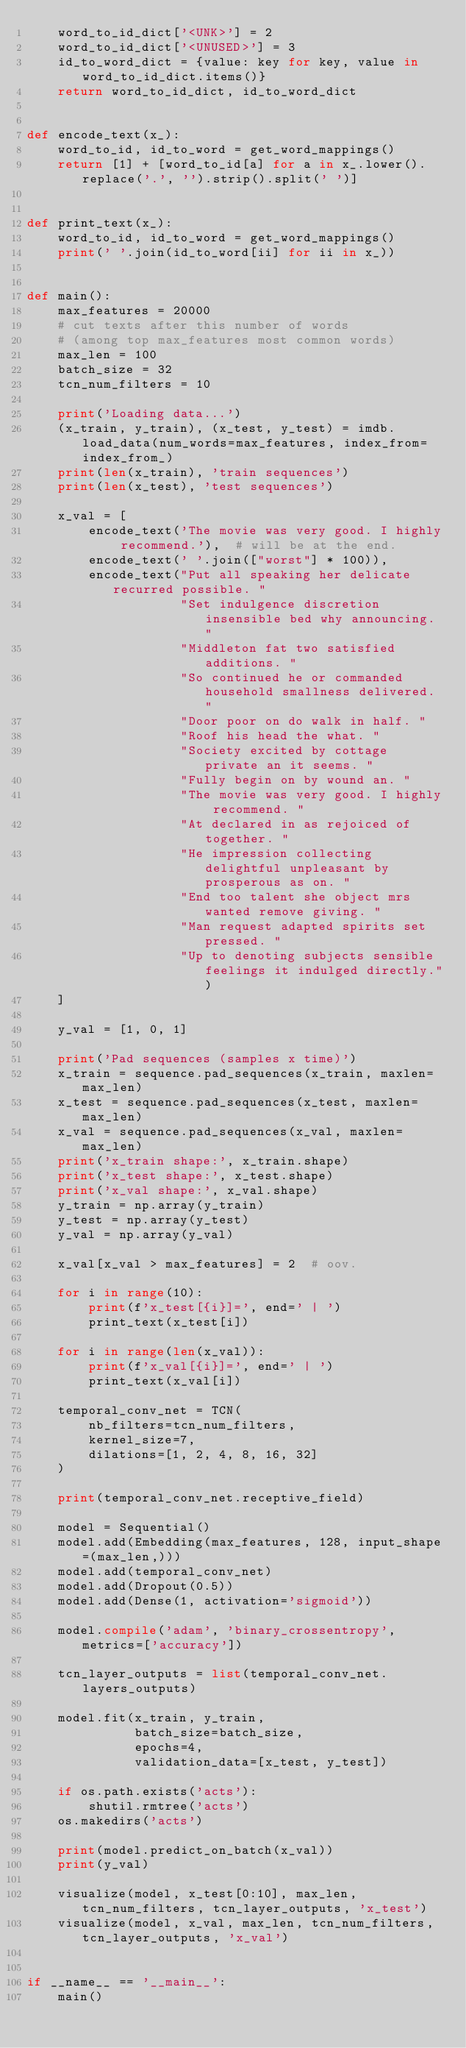Convert code to text. <code><loc_0><loc_0><loc_500><loc_500><_Python_>    word_to_id_dict['<UNK>'] = 2
    word_to_id_dict['<UNUSED>'] = 3
    id_to_word_dict = {value: key for key, value in word_to_id_dict.items()}
    return word_to_id_dict, id_to_word_dict


def encode_text(x_):
    word_to_id, id_to_word = get_word_mappings()
    return [1] + [word_to_id[a] for a in x_.lower().replace('.', '').strip().split(' ')]


def print_text(x_):
    word_to_id, id_to_word = get_word_mappings()
    print(' '.join(id_to_word[ii] for ii in x_))


def main():
    max_features = 20000
    # cut texts after this number of words
    # (among top max_features most common words)
    max_len = 100
    batch_size = 32
    tcn_num_filters = 10

    print('Loading data...')
    (x_train, y_train), (x_test, y_test) = imdb.load_data(num_words=max_features, index_from=index_from_)
    print(len(x_train), 'train sequences')
    print(len(x_test), 'test sequences')

    x_val = [
        encode_text('The movie was very good. I highly recommend.'),  # will be at the end.
        encode_text(' '.join(["worst"] * 100)),
        encode_text("Put all speaking her delicate recurred possible. "
                    "Set indulgence discretion insensible bed why announcing. "
                    "Middleton fat two satisfied additions. "
                    "So continued he or commanded household smallness delivered. "
                    "Door poor on do walk in half. "
                    "Roof his head the what. "
                    "Society excited by cottage private an it seems. "
                    "Fully begin on by wound an. "
                    "The movie was very good. I highly recommend. "
                    "At declared in as rejoiced of together. "
                    "He impression collecting delightful unpleasant by prosperous as on. "
                    "End too talent she object mrs wanted remove giving. "
                    "Man request adapted spirits set pressed. "
                    "Up to denoting subjects sensible feelings it indulged directly.")
    ]

    y_val = [1, 0, 1]

    print('Pad sequences (samples x time)')
    x_train = sequence.pad_sequences(x_train, maxlen=max_len)
    x_test = sequence.pad_sequences(x_test, maxlen=max_len)
    x_val = sequence.pad_sequences(x_val, maxlen=max_len)
    print('x_train shape:', x_train.shape)
    print('x_test shape:', x_test.shape)
    print('x_val shape:', x_val.shape)
    y_train = np.array(y_train)
    y_test = np.array(y_test)
    y_val = np.array(y_val)

    x_val[x_val > max_features] = 2  # oov.

    for i in range(10):
        print(f'x_test[{i}]=', end=' | ')
        print_text(x_test[i])

    for i in range(len(x_val)):
        print(f'x_val[{i}]=', end=' | ')
        print_text(x_val[i])

    temporal_conv_net = TCN(
        nb_filters=tcn_num_filters,
        kernel_size=7,
        dilations=[1, 2, 4, 8, 16, 32]
    )

    print(temporal_conv_net.receptive_field)

    model = Sequential()
    model.add(Embedding(max_features, 128, input_shape=(max_len,)))
    model.add(temporal_conv_net)
    model.add(Dropout(0.5))
    model.add(Dense(1, activation='sigmoid'))

    model.compile('adam', 'binary_crossentropy', metrics=['accuracy'])

    tcn_layer_outputs = list(temporal_conv_net.layers_outputs)

    model.fit(x_train, y_train,
              batch_size=batch_size,
              epochs=4,
              validation_data=[x_test, y_test])

    if os.path.exists('acts'):
        shutil.rmtree('acts')
    os.makedirs('acts')

    print(model.predict_on_batch(x_val))
    print(y_val)

    visualize(model, x_test[0:10], max_len, tcn_num_filters, tcn_layer_outputs, 'x_test')
    visualize(model, x_val, max_len, tcn_num_filters, tcn_layer_outputs, 'x_val')


if __name__ == '__main__':
    main()
</code> 